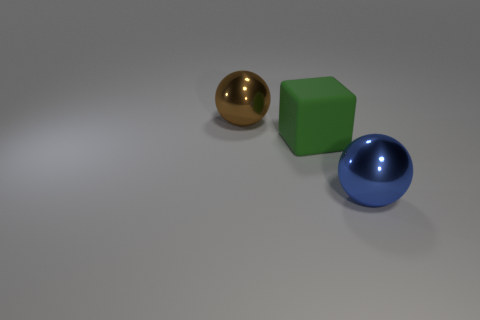What is the color of the big object that is both on the right side of the brown ball and behind the big blue metallic thing?
Provide a succinct answer. Green. How big is the ball left of the metallic object that is in front of the brown ball?
Give a very brief answer. Large. Are there any large metal objects of the same color as the large rubber object?
Offer a terse response. No. Are there the same number of shiny balls to the right of the blue metal ball and big rubber objects?
Your response must be concise. No. What number of big cyan objects are there?
Give a very brief answer. 0. What shape is the big thing that is in front of the brown sphere and left of the blue metal object?
Provide a succinct answer. Cube. Is the color of the metal thing right of the green rubber thing the same as the metal sphere behind the large blue sphere?
Ensure brevity in your answer.  No. Is there a green thing made of the same material as the large cube?
Give a very brief answer. No. Is the number of large green things that are in front of the big brown shiny sphere the same as the number of things that are in front of the block?
Keep it short and to the point. Yes. How big is the metallic thing that is behind the blue metallic object?
Keep it short and to the point. Large. 